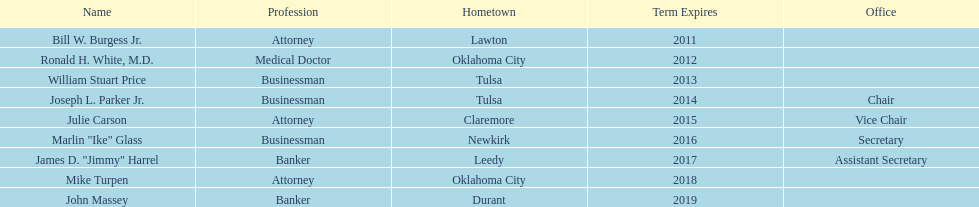Who are the trustees? Bill W. Burgess Jr., Ronald H. White, M.D., William Stuart Price, Joseph L. Parker Jr., Julie Carson, Marlin "Ike" Glass, James D. "Jimmy" Harrel, Mike Turpen, John Massey. Among them, who is a commerce person? William Stuart Price, Joseph L. Parker Jr., Marlin "Ike" Glass. Of these, who comes from tulsa? William Stuart Price, Joseph L. Parker Jr. Of them, whose period ends in 2013? William Stuart Price. 